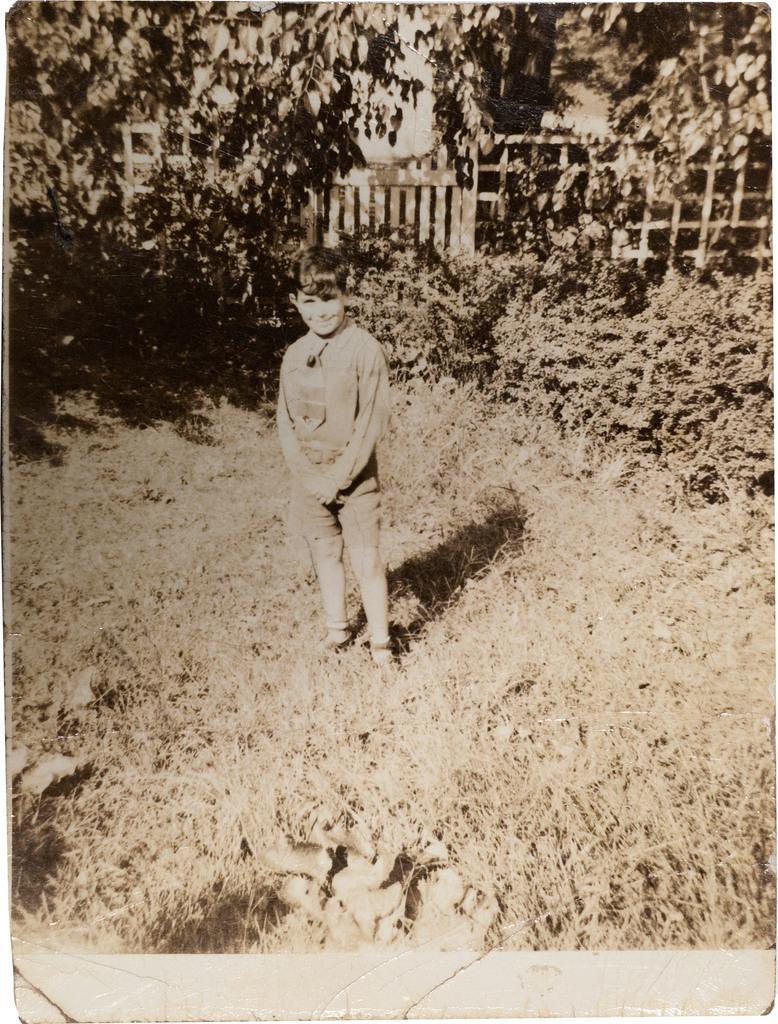Describe this image in one or two sentences. In this picture we can see a kid standing here, at the bottom there is grass, we can see trees in the background. 